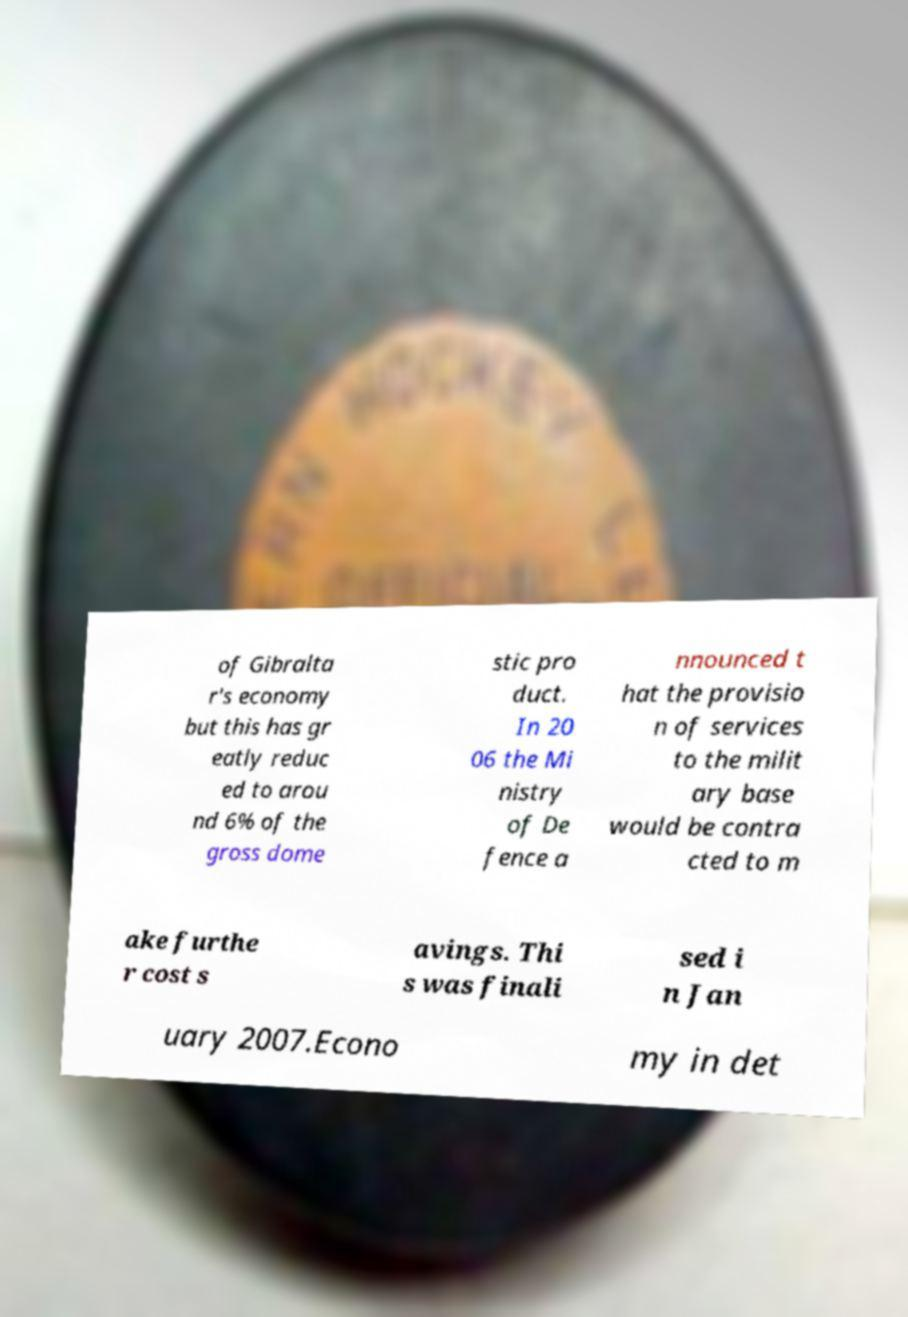Could you extract and type out the text from this image? of Gibralta r's economy but this has gr eatly reduc ed to arou nd 6% of the gross dome stic pro duct. In 20 06 the Mi nistry of De fence a nnounced t hat the provisio n of services to the milit ary base would be contra cted to m ake furthe r cost s avings. Thi s was finali sed i n Jan uary 2007.Econo my in det 